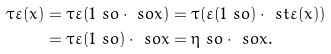<formula> <loc_0><loc_0><loc_500><loc_500>\tau \varepsilon ( x ) & = \tau \varepsilon ( 1 \ s o \cdot \ s o x ) = \tau ( \varepsilon ( 1 \ s o ) \cdot \ s t \varepsilon ( x ) ) \\ & = \tau \varepsilon ( 1 \ s o ) \cdot \ s o x = \eta \ s o \cdot \ s o x .</formula> 